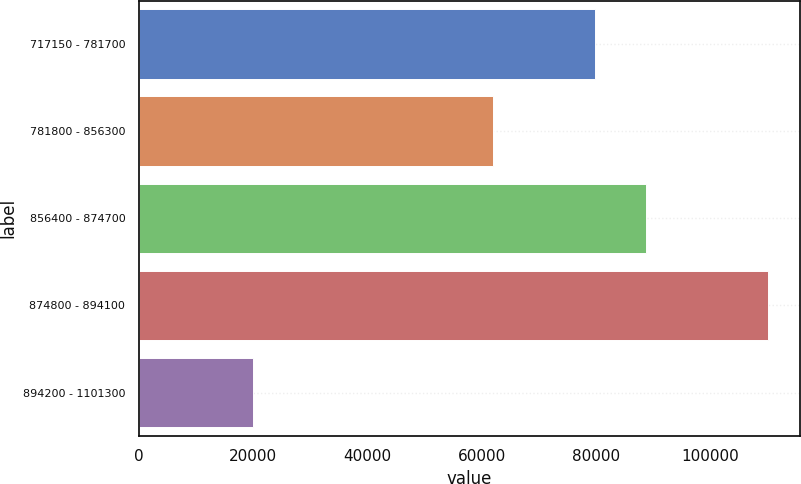Convert chart. <chart><loc_0><loc_0><loc_500><loc_500><bar_chart><fcel>717150 - 781700<fcel>781800 - 856300<fcel>856400 - 874700<fcel>874800 - 894100<fcel>894200 - 1101300<nl><fcel>79760<fcel>61900<fcel>88760.6<fcel>110060<fcel>20054<nl></chart> 